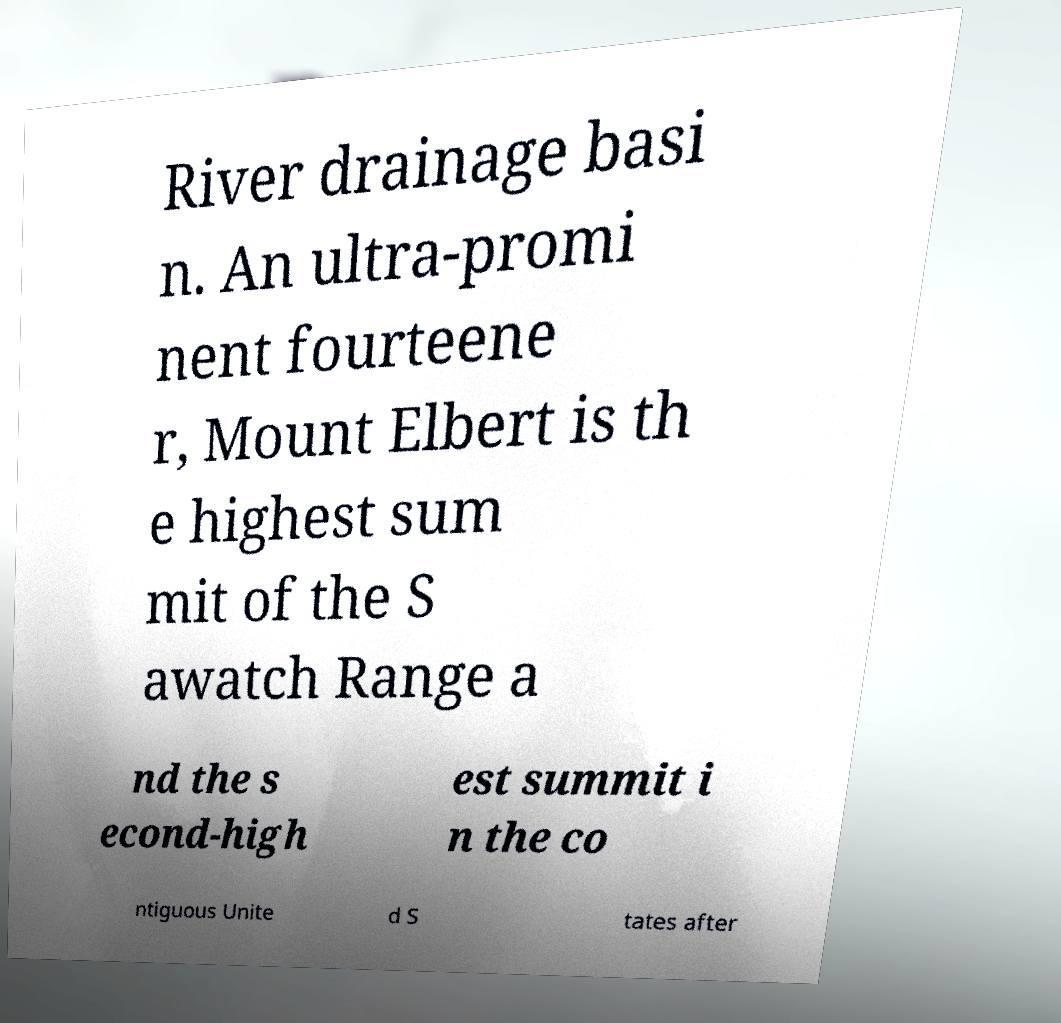Can you read and provide the text displayed in the image?This photo seems to have some interesting text. Can you extract and type it out for me? River drainage basi n. An ultra-promi nent fourteene r, Mount Elbert is th e highest sum mit of the S awatch Range a nd the s econd-high est summit i n the co ntiguous Unite d S tates after 